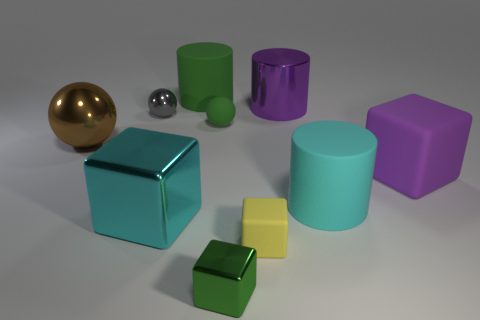Subtract all blocks. How many objects are left? 6 Add 9 large cyan cylinders. How many large cyan cylinders are left? 10 Add 2 tiny balls. How many tiny balls exist? 4 Subtract 0 yellow cylinders. How many objects are left? 10 Subtract all small purple balls. Subtract all small gray things. How many objects are left? 9 